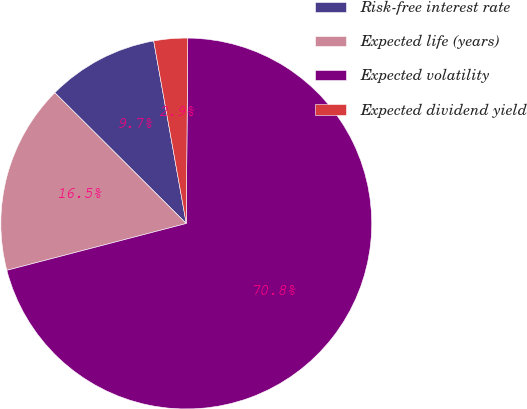<chart> <loc_0><loc_0><loc_500><loc_500><pie_chart><fcel>Risk-free interest rate<fcel>Expected life (years)<fcel>Expected volatility<fcel>Expected dividend yield<nl><fcel>9.73%<fcel>16.52%<fcel>70.81%<fcel>2.94%<nl></chart> 